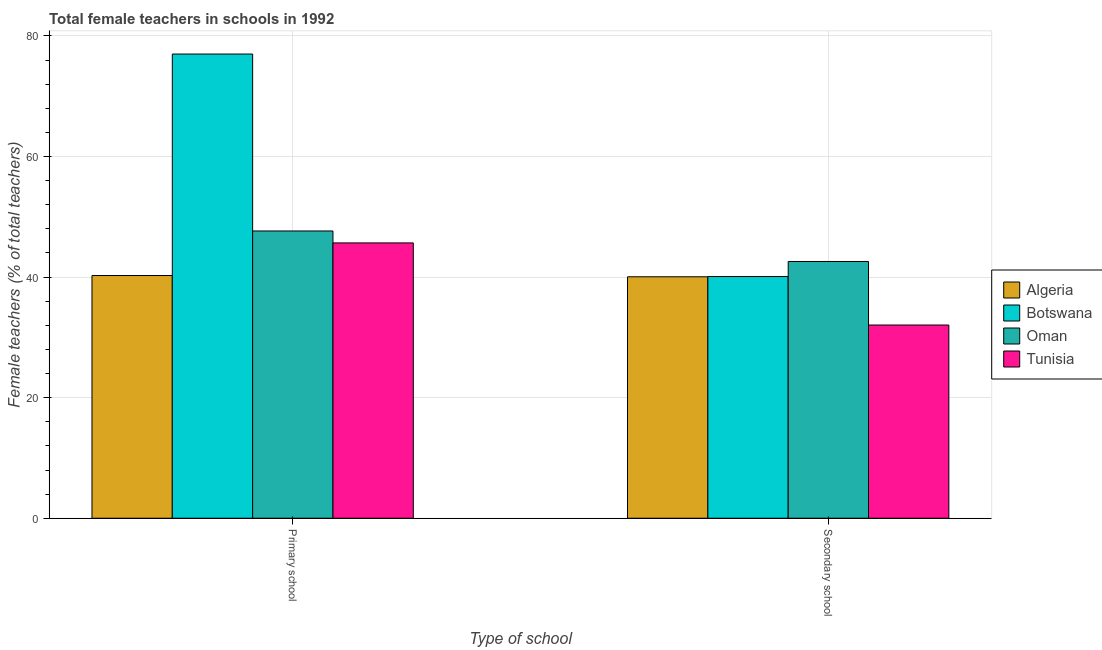How many groups of bars are there?
Offer a very short reply. 2. Are the number of bars per tick equal to the number of legend labels?
Make the answer very short. Yes. How many bars are there on the 1st tick from the left?
Provide a short and direct response. 4. How many bars are there on the 1st tick from the right?
Your response must be concise. 4. What is the label of the 1st group of bars from the left?
Provide a succinct answer. Primary school. What is the percentage of female teachers in primary schools in Oman?
Your answer should be compact. 47.65. Across all countries, what is the maximum percentage of female teachers in secondary schools?
Your response must be concise. 42.59. Across all countries, what is the minimum percentage of female teachers in primary schools?
Your answer should be compact. 40.26. In which country was the percentage of female teachers in primary schools maximum?
Offer a very short reply. Botswana. In which country was the percentage of female teachers in secondary schools minimum?
Ensure brevity in your answer.  Tunisia. What is the total percentage of female teachers in secondary schools in the graph?
Keep it short and to the point. 154.79. What is the difference between the percentage of female teachers in secondary schools in Tunisia and that in Oman?
Provide a succinct answer. -10.54. What is the difference between the percentage of female teachers in primary schools in Botswana and the percentage of female teachers in secondary schools in Oman?
Keep it short and to the point. 34.41. What is the average percentage of female teachers in primary schools per country?
Your answer should be very brief. 52.65. What is the difference between the percentage of female teachers in primary schools and percentage of female teachers in secondary schools in Oman?
Your answer should be compact. 5.06. What is the ratio of the percentage of female teachers in secondary schools in Tunisia to that in Botswana?
Provide a succinct answer. 0.8. Is the percentage of female teachers in primary schools in Oman less than that in Algeria?
Your answer should be very brief. No. In how many countries, is the percentage of female teachers in primary schools greater than the average percentage of female teachers in primary schools taken over all countries?
Give a very brief answer. 1. What does the 2nd bar from the left in Secondary school represents?
Ensure brevity in your answer.  Botswana. What does the 4th bar from the right in Secondary school represents?
Offer a terse response. Algeria. Are all the bars in the graph horizontal?
Your answer should be compact. No. What is the difference between two consecutive major ticks on the Y-axis?
Keep it short and to the point. 20. Does the graph contain any zero values?
Your answer should be compact. No. What is the title of the graph?
Your response must be concise. Total female teachers in schools in 1992. What is the label or title of the X-axis?
Keep it short and to the point. Type of school. What is the label or title of the Y-axis?
Offer a terse response. Female teachers (% of total teachers). What is the Female teachers (% of total teachers) in Algeria in Primary school?
Your response must be concise. 40.26. What is the Female teachers (% of total teachers) in Botswana in Primary school?
Make the answer very short. 77. What is the Female teachers (% of total teachers) in Oman in Primary school?
Your response must be concise. 47.65. What is the Female teachers (% of total teachers) in Tunisia in Primary school?
Provide a short and direct response. 45.67. What is the Female teachers (% of total teachers) of Algeria in Secondary school?
Offer a terse response. 40.05. What is the Female teachers (% of total teachers) of Botswana in Secondary school?
Your response must be concise. 40.09. What is the Female teachers (% of total teachers) of Oman in Secondary school?
Offer a terse response. 42.59. What is the Female teachers (% of total teachers) of Tunisia in Secondary school?
Provide a succinct answer. 32.05. Across all Type of school, what is the maximum Female teachers (% of total teachers) of Algeria?
Provide a succinct answer. 40.26. Across all Type of school, what is the maximum Female teachers (% of total teachers) of Botswana?
Offer a very short reply. 77. Across all Type of school, what is the maximum Female teachers (% of total teachers) of Oman?
Offer a terse response. 47.65. Across all Type of school, what is the maximum Female teachers (% of total teachers) of Tunisia?
Your answer should be very brief. 45.67. Across all Type of school, what is the minimum Female teachers (% of total teachers) of Algeria?
Provide a succinct answer. 40.05. Across all Type of school, what is the minimum Female teachers (% of total teachers) of Botswana?
Provide a short and direct response. 40.09. Across all Type of school, what is the minimum Female teachers (% of total teachers) in Oman?
Keep it short and to the point. 42.59. Across all Type of school, what is the minimum Female teachers (% of total teachers) of Tunisia?
Ensure brevity in your answer.  32.05. What is the total Female teachers (% of total teachers) in Algeria in the graph?
Your response must be concise. 80.31. What is the total Female teachers (% of total teachers) of Botswana in the graph?
Ensure brevity in your answer.  117.1. What is the total Female teachers (% of total teachers) of Oman in the graph?
Offer a terse response. 90.25. What is the total Female teachers (% of total teachers) in Tunisia in the graph?
Provide a short and direct response. 77.72. What is the difference between the Female teachers (% of total teachers) of Algeria in Primary school and that in Secondary school?
Provide a short and direct response. 0.21. What is the difference between the Female teachers (% of total teachers) of Botswana in Primary school and that in Secondary school?
Keep it short and to the point. 36.91. What is the difference between the Female teachers (% of total teachers) in Oman in Primary school and that in Secondary school?
Provide a short and direct response. 5.06. What is the difference between the Female teachers (% of total teachers) in Tunisia in Primary school and that in Secondary school?
Offer a very short reply. 13.62. What is the difference between the Female teachers (% of total teachers) of Algeria in Primary school and the Female teachers (% of total teachers) of Botswana in Secondary school?
Your answer should be very brief. 0.17. What is the difference between the Female teachers (% of total teachers) of Algeria in Primary school and the Female teachers (% of total teachers) of Oman in Secondary school?
Provide a succinct answer. -2.33. What is the difference between the Female teachers (% of total teachers) in Algeria in Primary school and the Female teachers (% of total teachers) in Tunisia in Secondary school?
Your response must be concise. 8.21. What is the difference between the Female teachers (% of total teachers) of Botswana in Primary school and the Female teachers (% of total teachers) of Oman in Secondary school?
Ensure brevity in your answer.  34.41. What is the difference between the Female teachers (% of total teachers) in Botswana in Primary school and the Female teachers (% of total teachers) in Tunisia in Secondary school?
Provide a succinct answer. 44.95. What is the difference between the Female teachers (% of total teachers) of Oman in Primary school and the Female teachers (% of total teachers) of Tunisia in Secondary school?
Keep it short and to the point. 15.6. What is the average Female teachers (% of total teachers) of Algeria per Type of school?
Offer a very short reply. 40.16. What is the average Female teachers (% of total teachers) in Botswana per Type of school?
Your answer should be compact. 58.55. What is the average Female teachers (% of total teachers) of Oman per Type of school?
Keep it short and to the point. 45.12. What is the average Female teachers (% of total teachers) in Tunisia per Type of school?
Give a very brief answer. 38.86. What is the difference between the Female teachers (% of total teachers) of Algeria and Female teachers (% of total teachers) of Botswana in Primary school?
Keep it short and to the point. -36.74. What is the difference between the Female teachers (% of total teachers) of Algeria and Female teachers (% of total teachers) of Oman in Primary school?
Give a very brief answer. -7.39. What is the difference between the Female teachers (% of total teachers) in Algeria and Female teachers (% of total teachers) in Tunisia in Primary school?
Provide a short and direct response. -5.41. What is the difference between the Female teachers (% of total teachers) of Botswana and Female teachers (% of total teachers) of Oman in Primary school?
Your answer should be compact. 29.35. What is the difference between the Female teachers (% of total teachers) in Botswana and Female teachers (% of total teachers) in Tunisia in Primary school?
Provide a short and direct response. 31.33. What is the difference between the Female teachers (% of total teachers) of Oman and Female teachers (% of total teachers) of Tunisia in Primary school?
Ensure brevity in your answer.  1.98. What is the difference between the Female teachers (% of total teachers) in Algeria and Female teachers (% of total teachers) in Botswana in Secondary school?
Make the answer very short. -0.04. What is the difference between the Female teachers (% of total teachers) of Algeria and Female teachers (% of total teachers) of Oman in Secondary school?
Give a very brief answer. -2.54. What is the difference between the Female teachers (% of total teachers) in Algeria and Female teachers (% of total teachers) in Tunisia in Secondary school?
Give a very brief answer. 8. What is the difference between the Female teachers (% of total teachers) in Botswana and Female teachers (% of total teachers) in Oman in Secondary school?
Ensure brevity in your answer.  -2.5. What is the difference between the Female teachers (% of total teachers) of Botswana and Female teachers (% of total teachers) of Tunisia in Secondary school?
Ensure brevity in your answer.  8.04. What is the difference between the Female teachers (% of total teachers) of Oman and Female teachers (% of total teachers) of Tunisia in Secondary school?
Keep it short and to the point. 10.54. What is the ratio of the Female teachers (% of total teachers) in Algeria in Primary school to that in Secondary school?
Give a very brief answer. 1.01. What is the ratio of the Female teachers (% of total teachers) of Botswana in Primary school to that in Secondary school?
Provide a succinct answer. 1.92. What is the ratio of the Female teachers (% of total teachers) of Oman in Primary school to that in Secondary school?
Give a very brief answer. 1.12. What is the ratio of the Female teachers (% of total teachers) of Tunisia in Primary school to that in Secondary school?
Make the answer very short. 1.43. What is the difference between the highest and the second highest Female teachers (% of total teachers) of Algeria?
Keep it short and to the point. 0.21. What is the difference between the highest and the second highest Female teachers (% of total teachers) in Botswana?
Your answer should be compact. 36.91. What is the difference between the highest and the second highest Female teachers (% of total teachers) of Oman?
Offer a very short reply. 5.06. What is the difference between the highest and the second highest Female teachers (% of total teachers) in Tunisia?
Give a very brief answer. 13.62. What is the difference between the highest and the lowest Female teachers (% of total teachers) in Algeria?
Keep it short and to the point. 0.21. What is the difference between the highest and the lowest Female teachers (% of total teachers) of Botswana?
Ensure brevity in your answer.  36.91. What is the difference between the highest and the lowest Female teachers (% of total teachers) in Oman?
Ensure brevity in your answer.  5.06. What is the difference between the highest and the lowest Female teachers (% of total teachers) of Tunisia?
Offer a terse response. 13.62. 